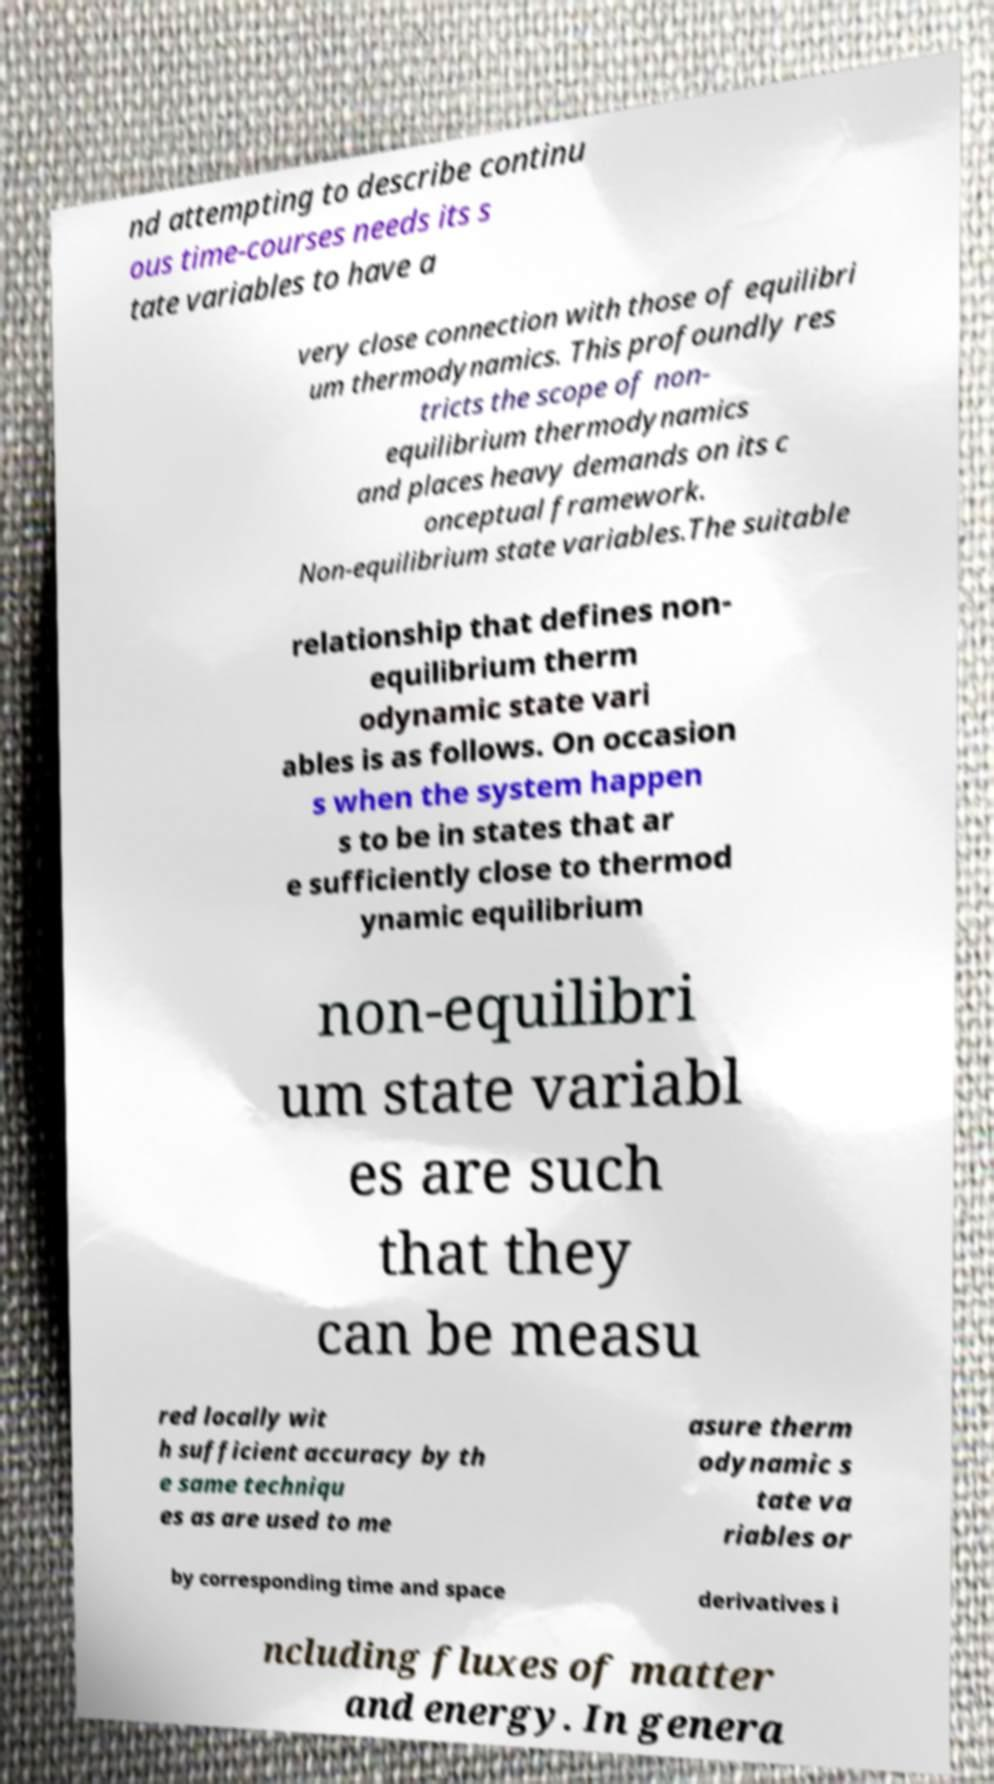Could you extract and type out the text from this image? nd attempting to describe continu ous time-courses needs its s tate variables to have a very close connection with those of equilibri um thermodynamics. This profoundly res tricts the scope of non- equilibrium thermodynamics and places heavy demands on its c onceptual framework. Non-equilibrium state variables.The suitable relationship that defines non- equilibrium therm odynamic state vari ables is as follows. On occasion s when the system happen s to be in states that ar e sufficiently close to thermod ynamic equilibrium non-equilibri um state variabl es are such that they can be measu red locally wit h sufficient accuracy by th e same techniqu es as are used to me asure therm odynamic s tate va riables or by corresponding time and space derivatives i ncluding fluxes of matter and energy. In genera 